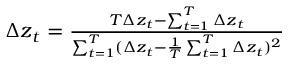Convert formula to latex. <formula><loc_0><loc_0><loc_500><loc_500>\begin{array} { r } { \Delta z _ { t } = \frac { T \Delta z _ { t } - \sum _ { t = 1 } ^ { T } \Delta z _ { t } } { \sum _ { t = 1 } ^ { T } ( \Delta z _ { t } - \frac { 1 } { T } \sum _ { t = 1 } ^ { T } \Delta z _ { t } ) ^ { 2 } } } \end{array}</formula> 